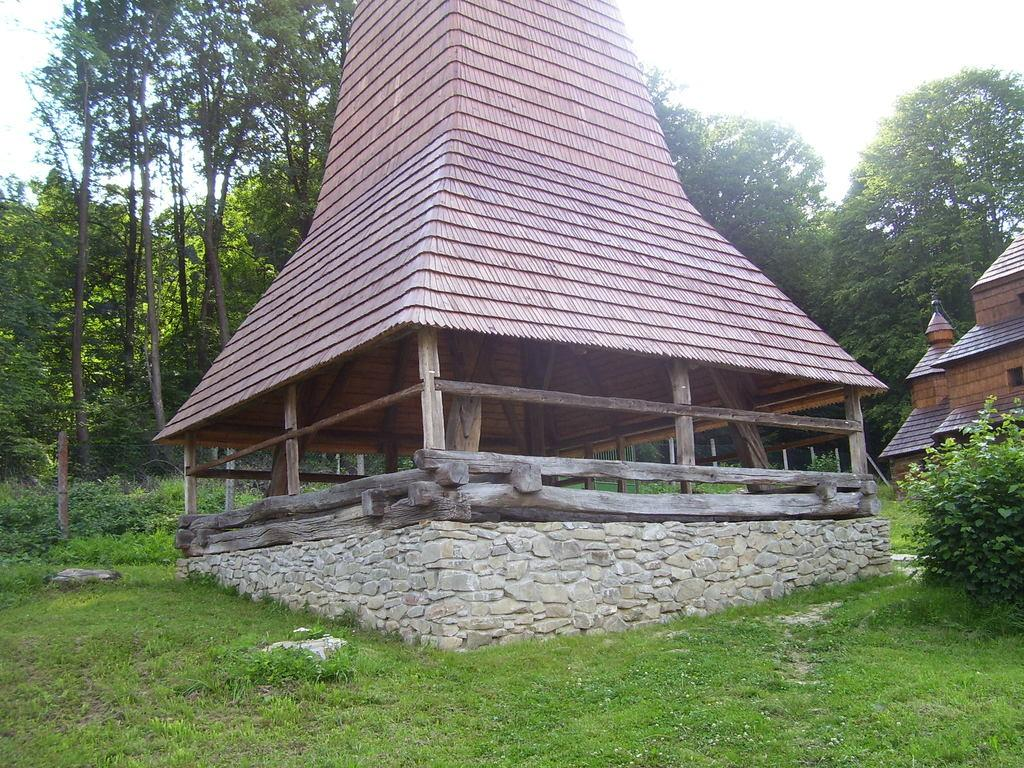What type of structures can be seen in the image? There are buildings in the image. What is the ground covered with? The ground is covered with grass. What can be seen in the background of the image? There are many trees visible in the background. What type of coat is draped over the tree in the image? There is no coat draped over any tree in the image; only buildings, grass, and trees are present. 